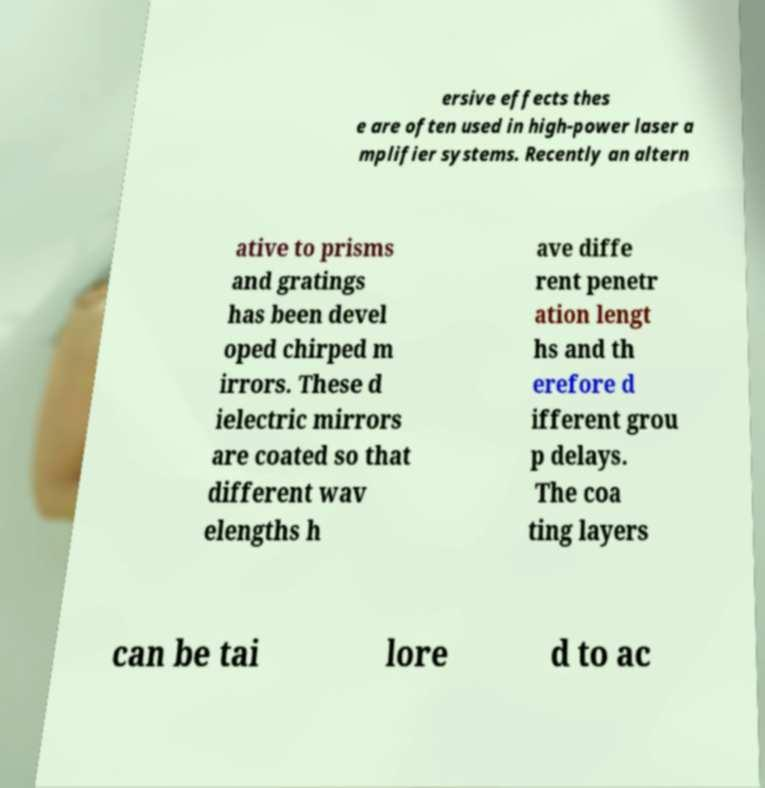What messages or text are displayed in this image? I need them in a readable, typed format. ersive effects thes e are often used in high-power laser a mplifier systems. Recently an altern ative to prisms and gratings has been devel oped chirped m irrors. These d ielectric mirrors are coated so that different wav elengths h ave diffe rent penetr ation lengt hs and th erefore d ifferent grou p delays. The coa ting layers can be tai lore d to ac 